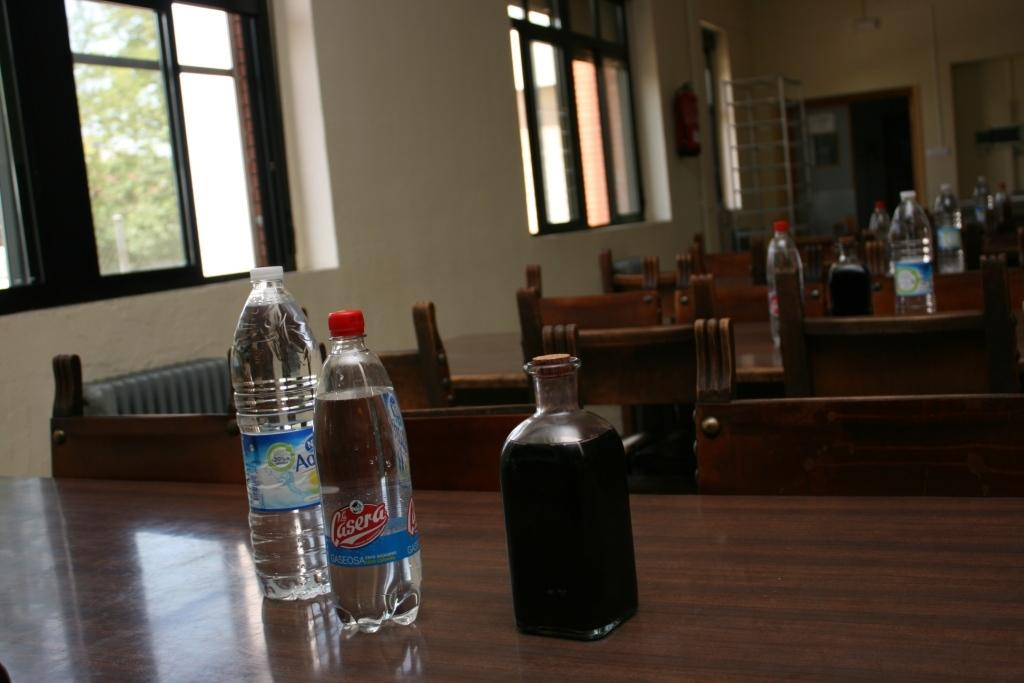<image>
Render a clear and concise summary of the photo. A row of tables that each have a bottle of Lasera along with two others on them. 